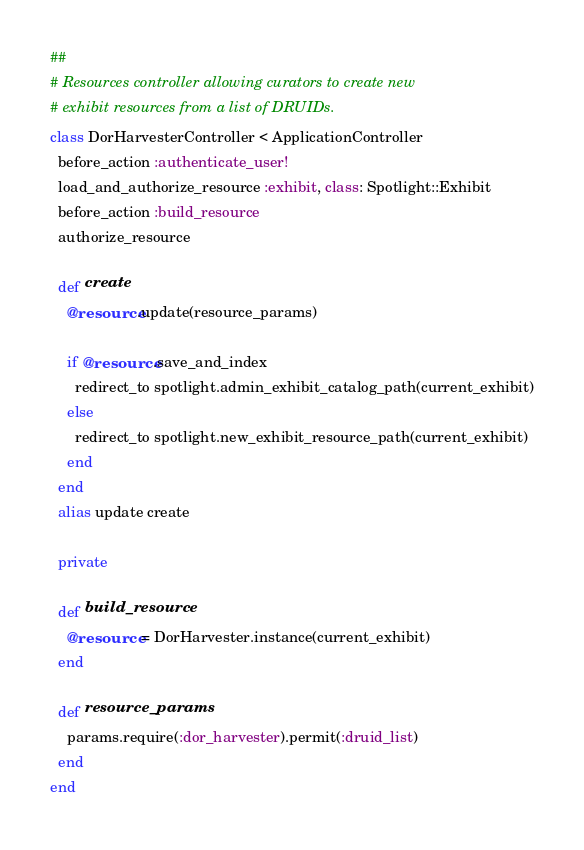Convert code to text. <code><loc_0><loc_0><loc_500><loc_500><_Ruby_>##
# Resources controller allowing curators to create new
# exhibit resources from a list of DRUIDs.
class DorHarvesterController < ApplicationController
  before_action :authenticate_user!
  load_and_authorize_resource :exhibit, class: Spotlight::Exhibit
  before_action :build_resource
  authorize_resource

  def create
    @resource.update(resource_params)

    if @resource.save_and_index
      redirect_to spotlight.admin_exhibit_catalog_path(current_exhibit)
    else
      redirect_to spotlight.new_exhibit_resource_path(current_exhibit)
    end
  end
  alias update create

  private

  def build_resource
    @resource = DorHarvester.instance(current_exhibit)
  end

  def resource_params
    params.require(:dor_harvester).permit(:druid_list)
  end
end
</code> 